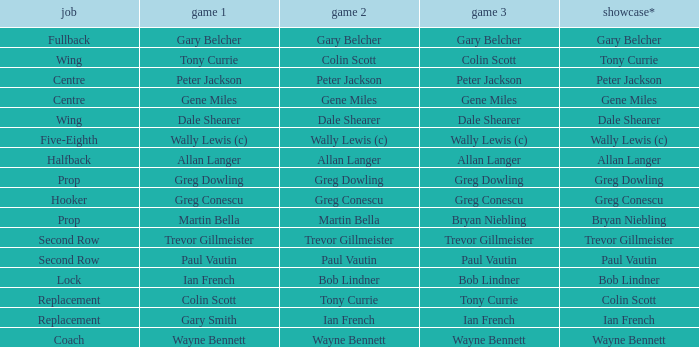Wjat game 3 has ian french as a game of 2? Ian French. 